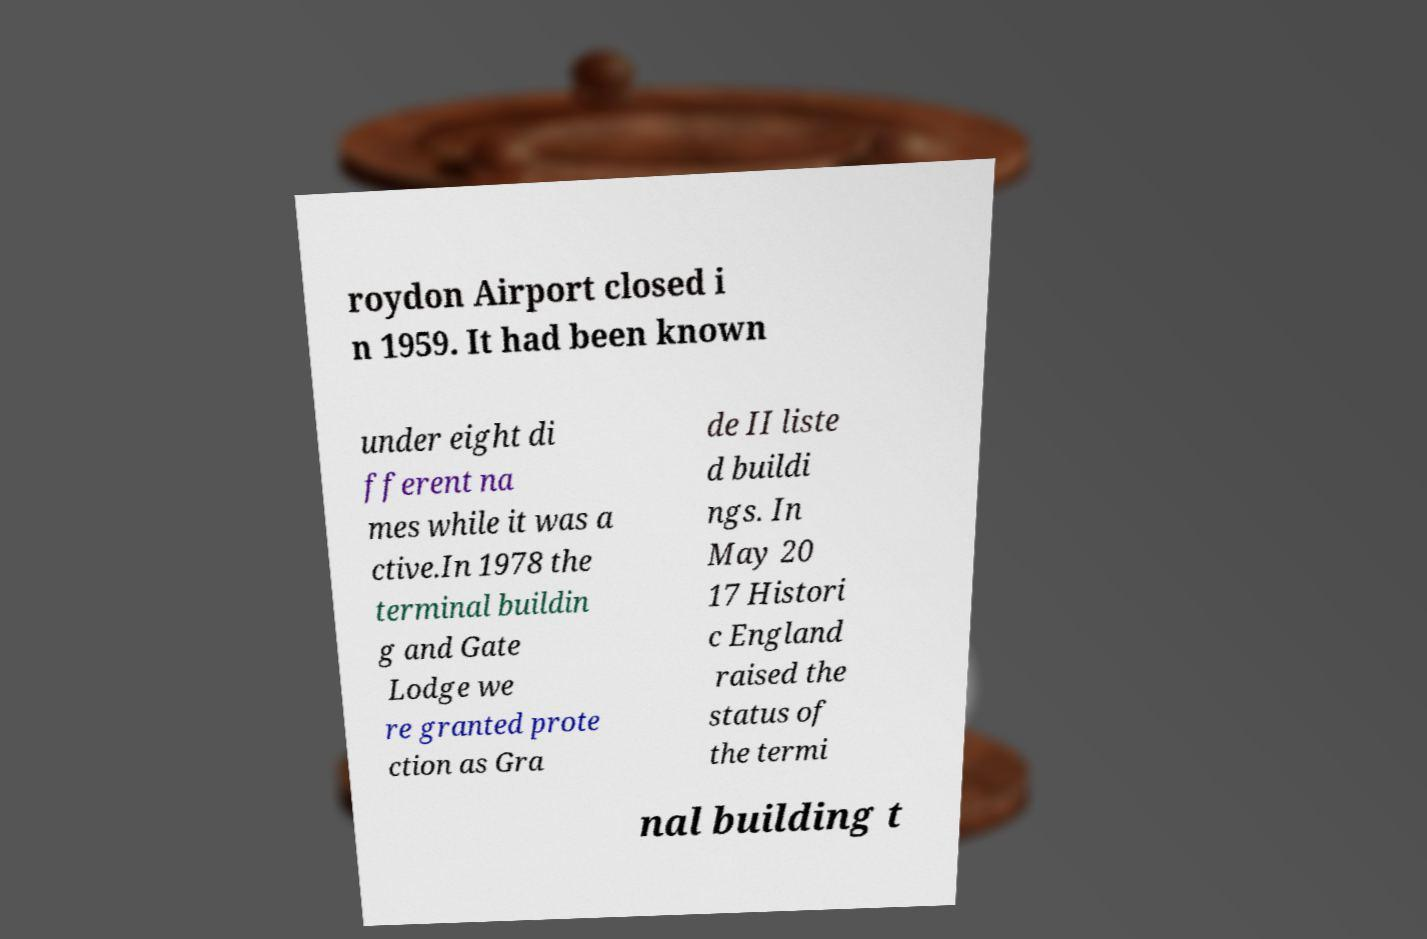I need the written content from this picture converted into text. Can you do that? roydon Airport closed i n 1959. It had been known under eight di fferent na mes while it was a ctive.In 1978 the terminal buildin g and Gate Lodge we re granted prote ction as Gra de II liste d buildi ngs. In May 20 17 Histori c England raised the status of the termi nal building t 